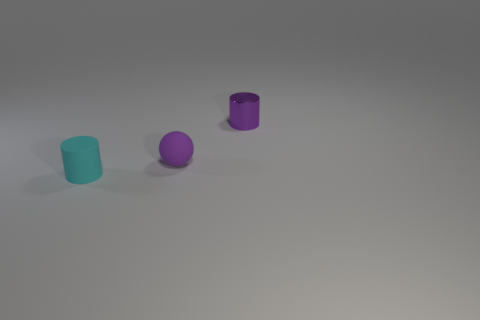What is the material of the cyan object that is the same size as the purple matte ball?
Your response must be concise. Rubber. Is there a large yellow cylinder made of the same material as the tiny sphere?
Make the answer very short. No. There is a tiny object that is both left of the metal cylinder and right of the tiny rubber cylinder; what color is it?
Your response must be concise. Purple. How many other things are the same color as the matte cylinder?
Offer a terse response. 0. There is a small cyan thing that is on the left side of the rubber object that is behind the cylinder that is left of the tiny purple shiny cylinder; what is its material?
Make the answer very short. Rubber. How many blocks are either cyan rubber objects or metal things?
Ensure brevity in your answer.  0. Is there any other thing that is the same size as the ball?
Your response must be concise. Yes. What number of rubber cylinders are to the left of the matte object that is on the right side of the rubber object in front of the small sphere?
Give a very brief answer. 1. Is the shape of the metal object the same as the cyan object?
Give a very brief answer. Yes. Do the small cylinder in front of the small purple ball and the object that is behind the small matte sphere have the same material?
Keep it short and to the point. No. 